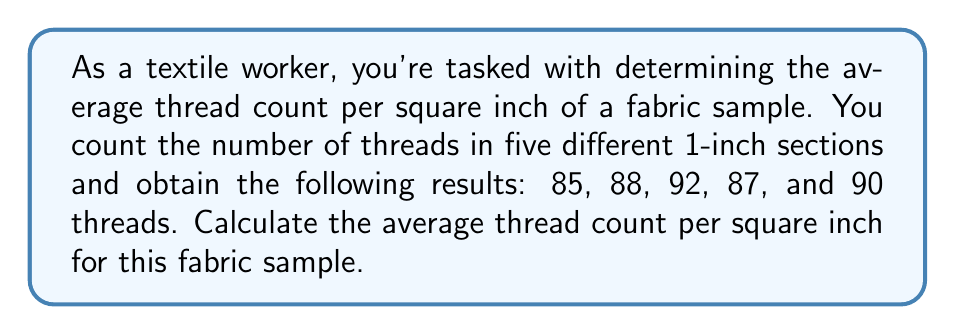Could you help me with this problem? To calculate the average thread count per square inch, we'll follow these steps:

1. Sum up all the thread counts:
   $$ 85 + 88 + 92 + 87 + 90 = 442 $$

2. Count the number of measurements:
   There are 5 measurements.

3. Calculate the average by dividing the sum by the number of measurements:
   $$ \text{Average} = \frac{\text{Sum of measurements}}{\text{Number of measurements}} $$
   $$ \text{Average} = \frac{442}{5} = 88.4 $$

Therefore, the average thread count per square inch is 88.4 threads.
Answer: 88.4 threads per square inch 